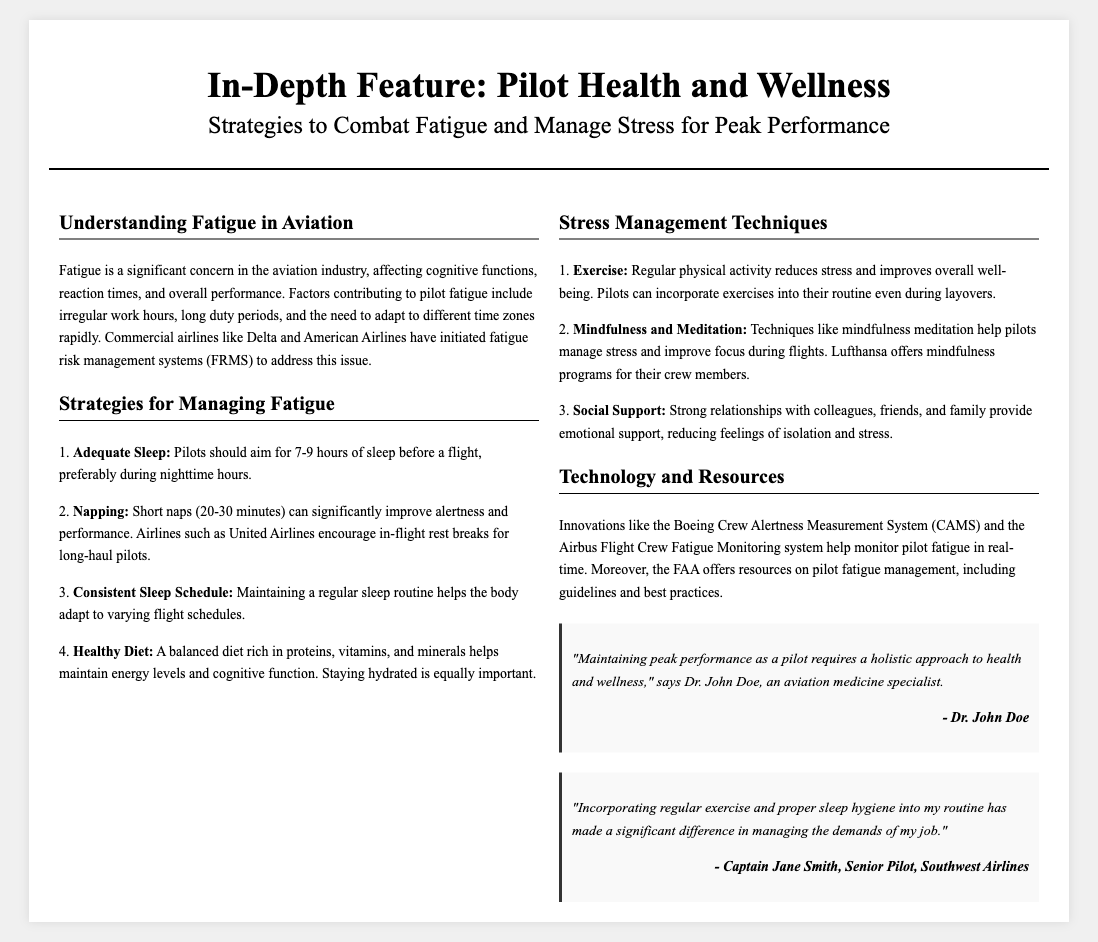What is the title of the article? The title of the article is the main headline that introduces the topic discussed, which is "In-Depth Feature: Pilot Health and Wellness".
Answer: In-Depth Feature: Pilot Health and Wellness What is one strategy for managing fatigue? The document lists several strategies for managing fatigue; one example is provided in the context of adequate sleep.
Answer: Adequate Sleep Who is a source quoted in the testimonials? This refers to an individual providing insights in the testimonials section of the document, specifically Dr. John Doe.
Answer: Dr. John Doe What type of physical activity is mentioned as a stress management technique? The document highlights that regular physical activity is a technique to reduce stress.
Answer: Exercise Which airline encourages in-flight rest breaks? This is a specific detail about an airline's policy towards managing pilot fatigue mentioned in the document.
Answer: United Airlines How many hours of sleep should pilots aim for before a flight? The recommended amount of sleep for pilots before flying is mentioned in the strategies section.
Answer: 7-9 hours What type of system helps monitor pilot fatigue in real-time? The document references technologies specifically designed for this purpose, including the Boeing Crew Alertness Measurement System.
Answer: Boeing Crew Alertness Measurement System What does the document suggest about maintaining a consistent schedule? The context provided relates to how it helps pilots, as mentioned in one of the strategies.
Answer: Consistent Sleep Schedule 